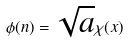Convert formula to latex. <formula><loc_0><loc_0><loc_500><loc_500>\phi ( n ) = \sqrt { a } \chi ( x )</formula> 